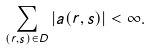Convert formula to latex. <formula><loc_0><loc_0><loc_500><loc_500>\sum _ { ( r , s ) \in D } | a ( r , s ) | < \infty .</formula> 